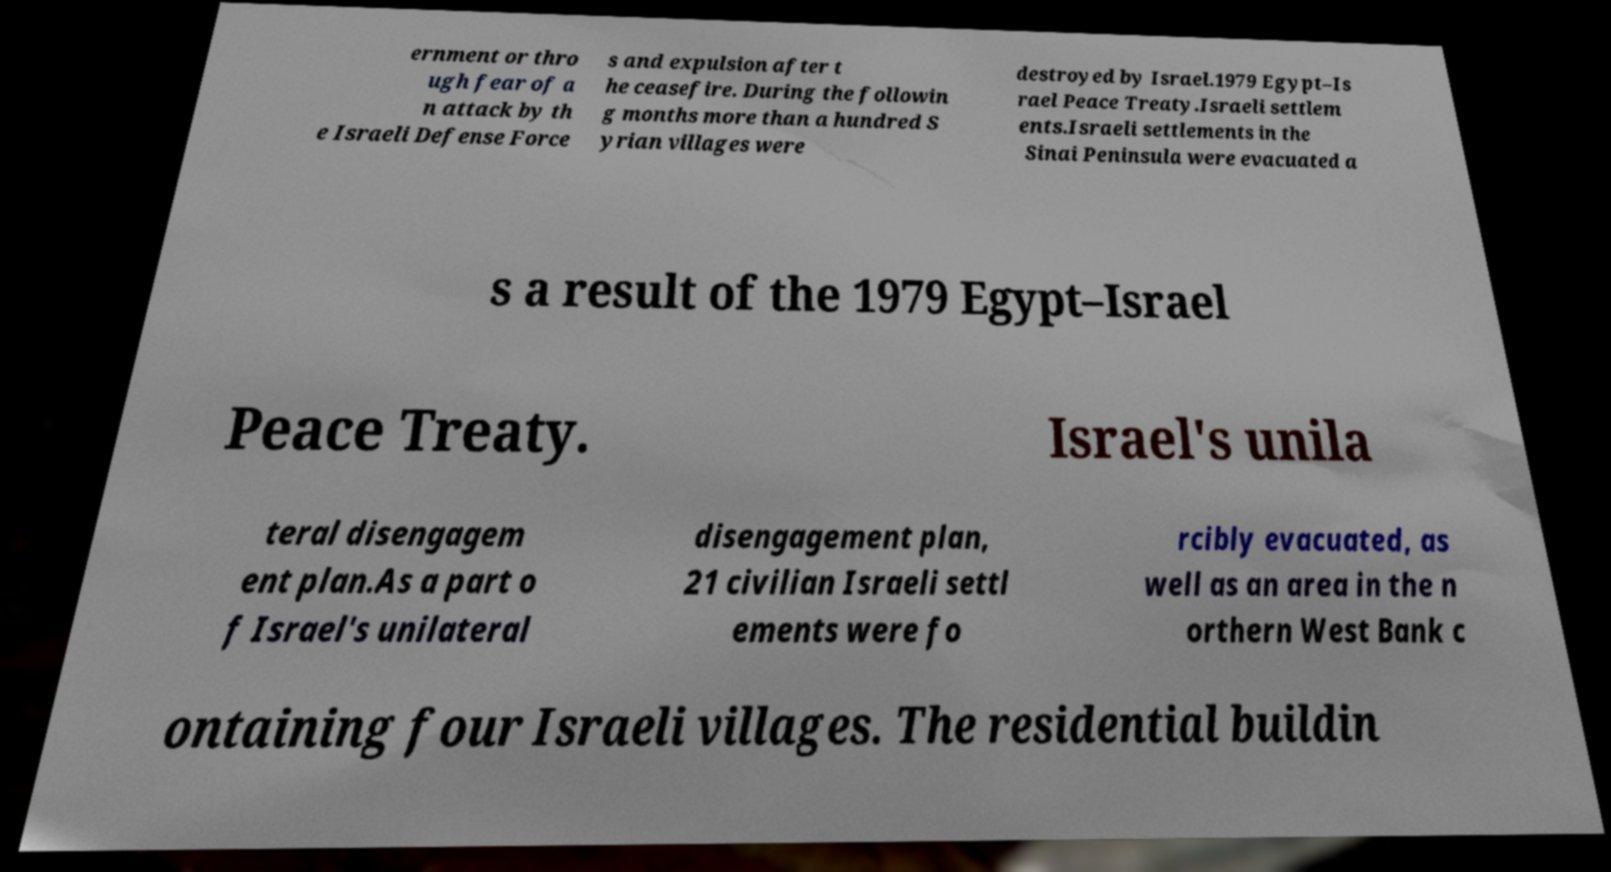Can you read and provide the text displayed in the image?This photo seems to have some interesting text. Can you extract and type it out for me? ernment or thro ugh fear of a n attack by th e Israeli Defense Force s and expulsion after t he ceasefire. During the followin g months more than a hundred S yrian villages were destroyed by Israel.1979 Egypt–Is rael Peace Treaty.Israeli settlem ents.Israeli settlements in the Sinai Peninsula were evacuated a s a result of the 1979 Egypt–Israel Peace Treaty. Israel's unila teral disengagem ent plan.As a part o f Israel's unilateral disengagement plan, 21 civilian Israeli settl ements were fo rcibly evacuated, as well as an area in the n orthern West Bank c ontaining four Israeli villages. The residential buildin 